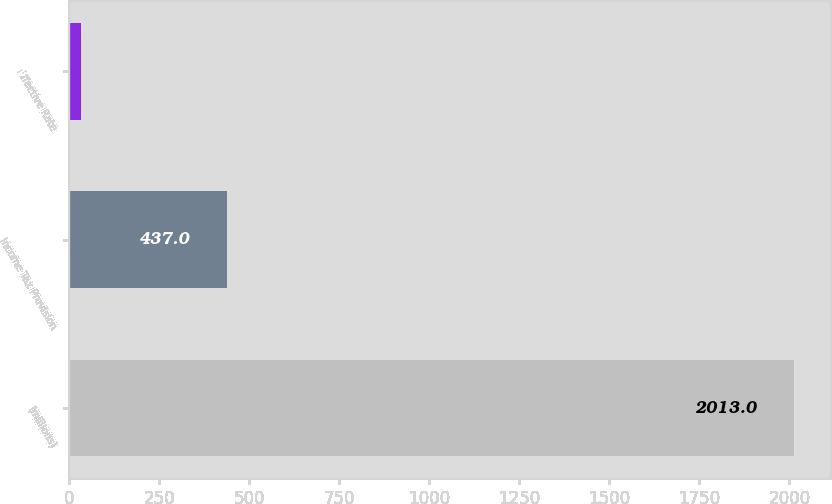Convert chart. <chart><loc_0><loc_0><loc_500><loc_500><bar_chart><fcel>(millions)<fcel>Income Tax Provision<fcel>Effective Rate<nl><fcel>2013<fcel>437<fcel>32.5<nl></chart> 